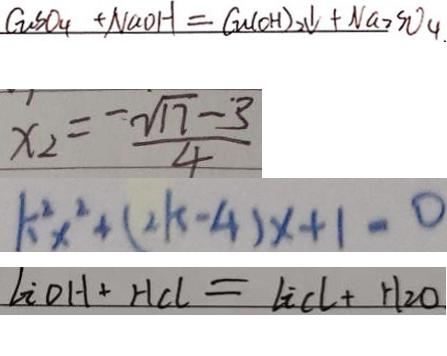<formula> <loc_0><loc_0><loc_500><loc_500>G _ { u } S O _ { 4 } + N a O H = G u ( O H ) _ { 2 } \downarrow + N a _ { 2 } S O _ { 4 } . 
 x _ { 2 } = \frac { - \sqrt { 1 7 } - 3 } { 4 } 
 k ^ { 2 } x ^ { 2 } + ( 2 k - 4 ) x + 1 = 0 
 l i o H + H C l = l i C l + H _ { 2 } O</formula> 